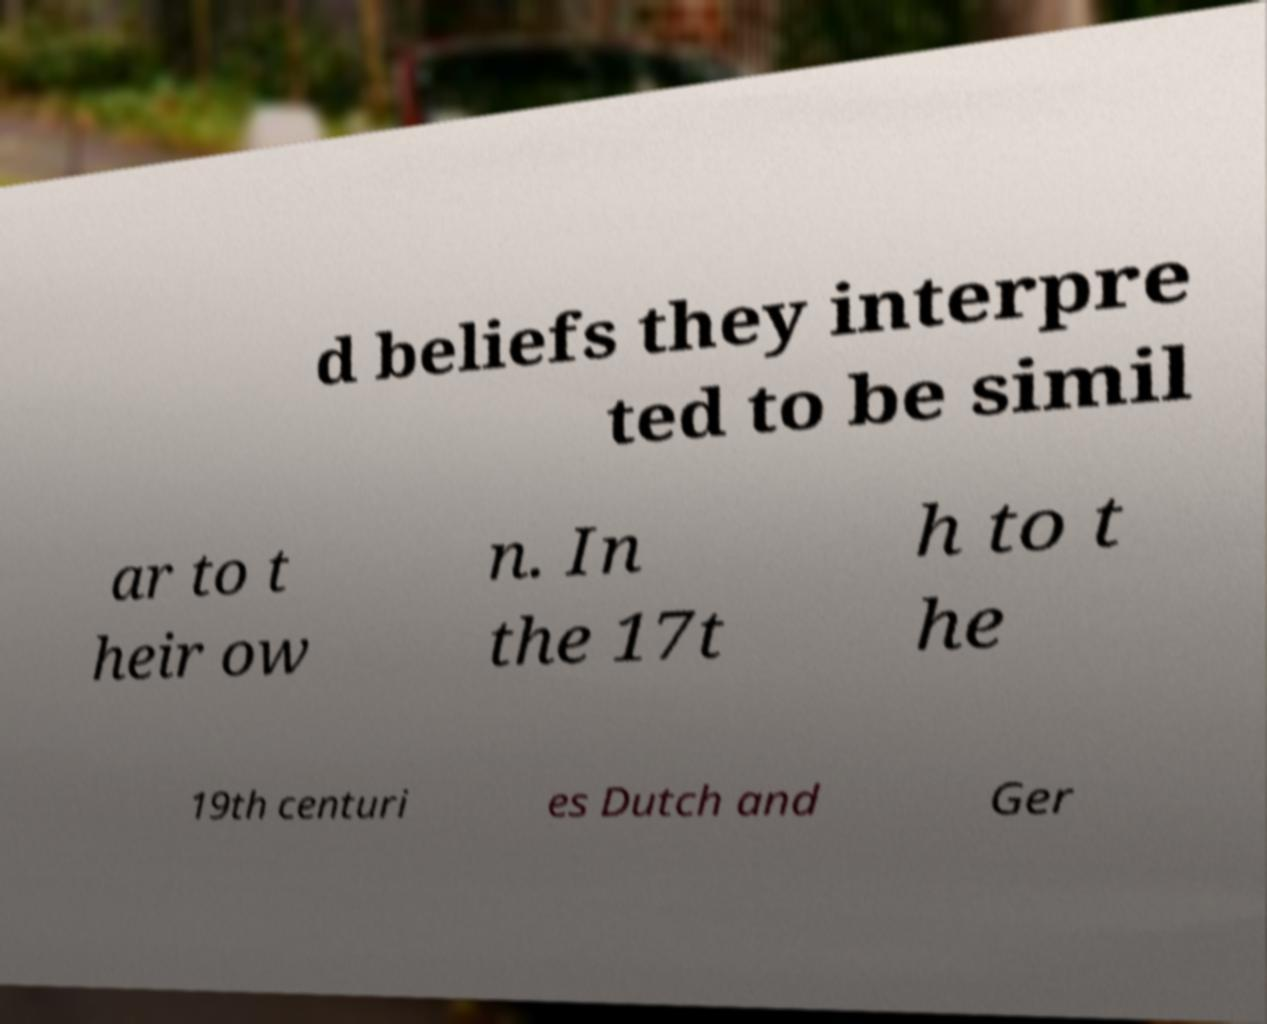Can you accurately transcribe the text from the provided image for me? d beliefs they interpre ted to be simil ar to t heir ow n. In the 17t h to t he 19th centuri es Dutch and Ger 